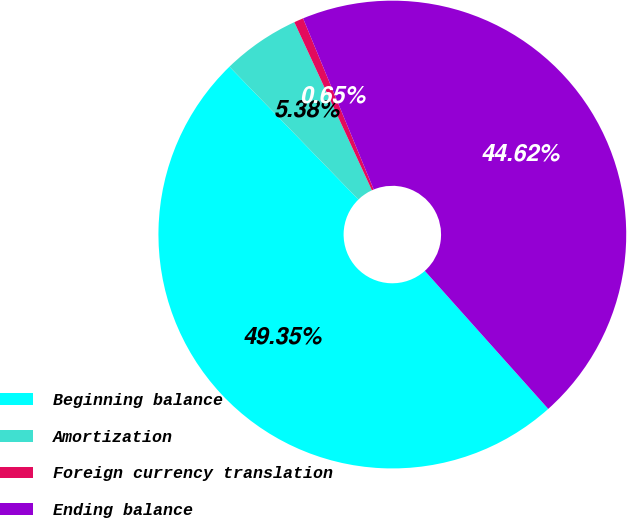Convert chart. <chart><loc_0><loc_0><loc_500><loc_500><pie_chart><fcel>Beginning balance<fcel>Amortization<fcel>Foreign currency translation<fcel>Ending balance<nl><fcel>49.35%<fcel>5.38%<fcel>0.65%<fcel>44.62%<nl></chart> 